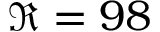<formula> <loc_0><loc_0><loc_500><loc_500>\Re = 9 8</formula> 